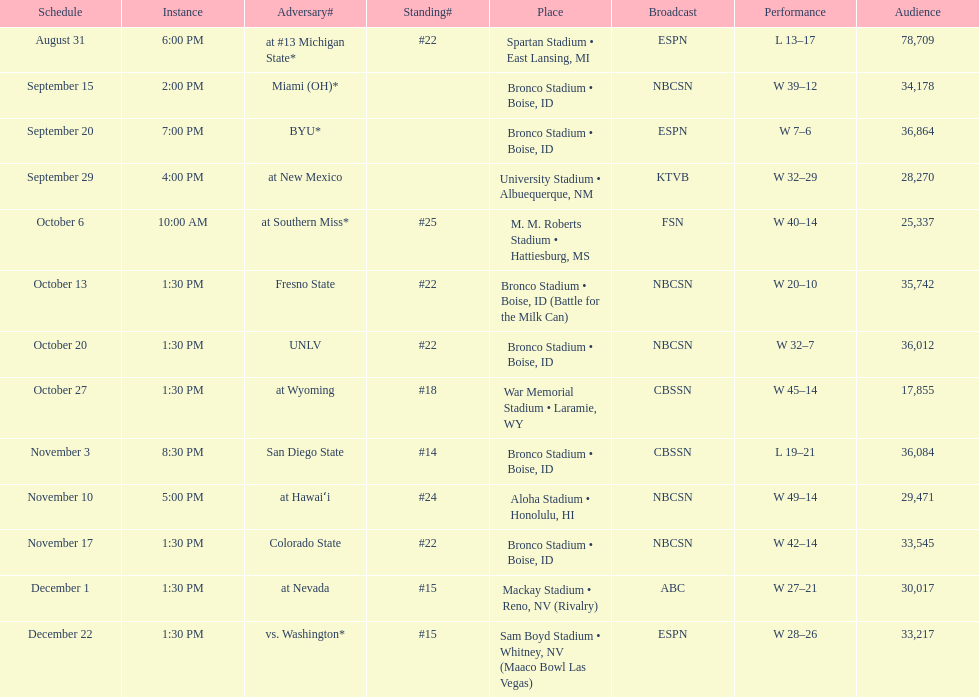How many games have taken place in bronco stadium in total? 6. 